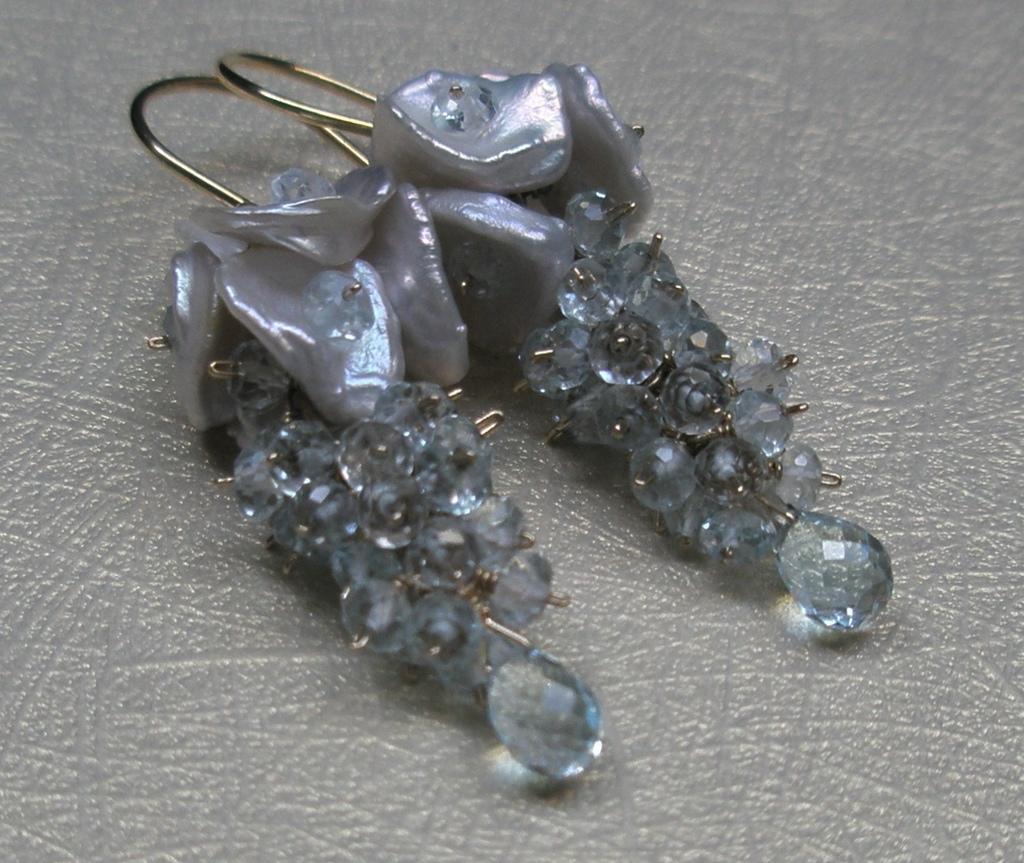Please provide a concise description of this image. In this image I can see the earrings which are in ash color. These are on the ash color surface. 